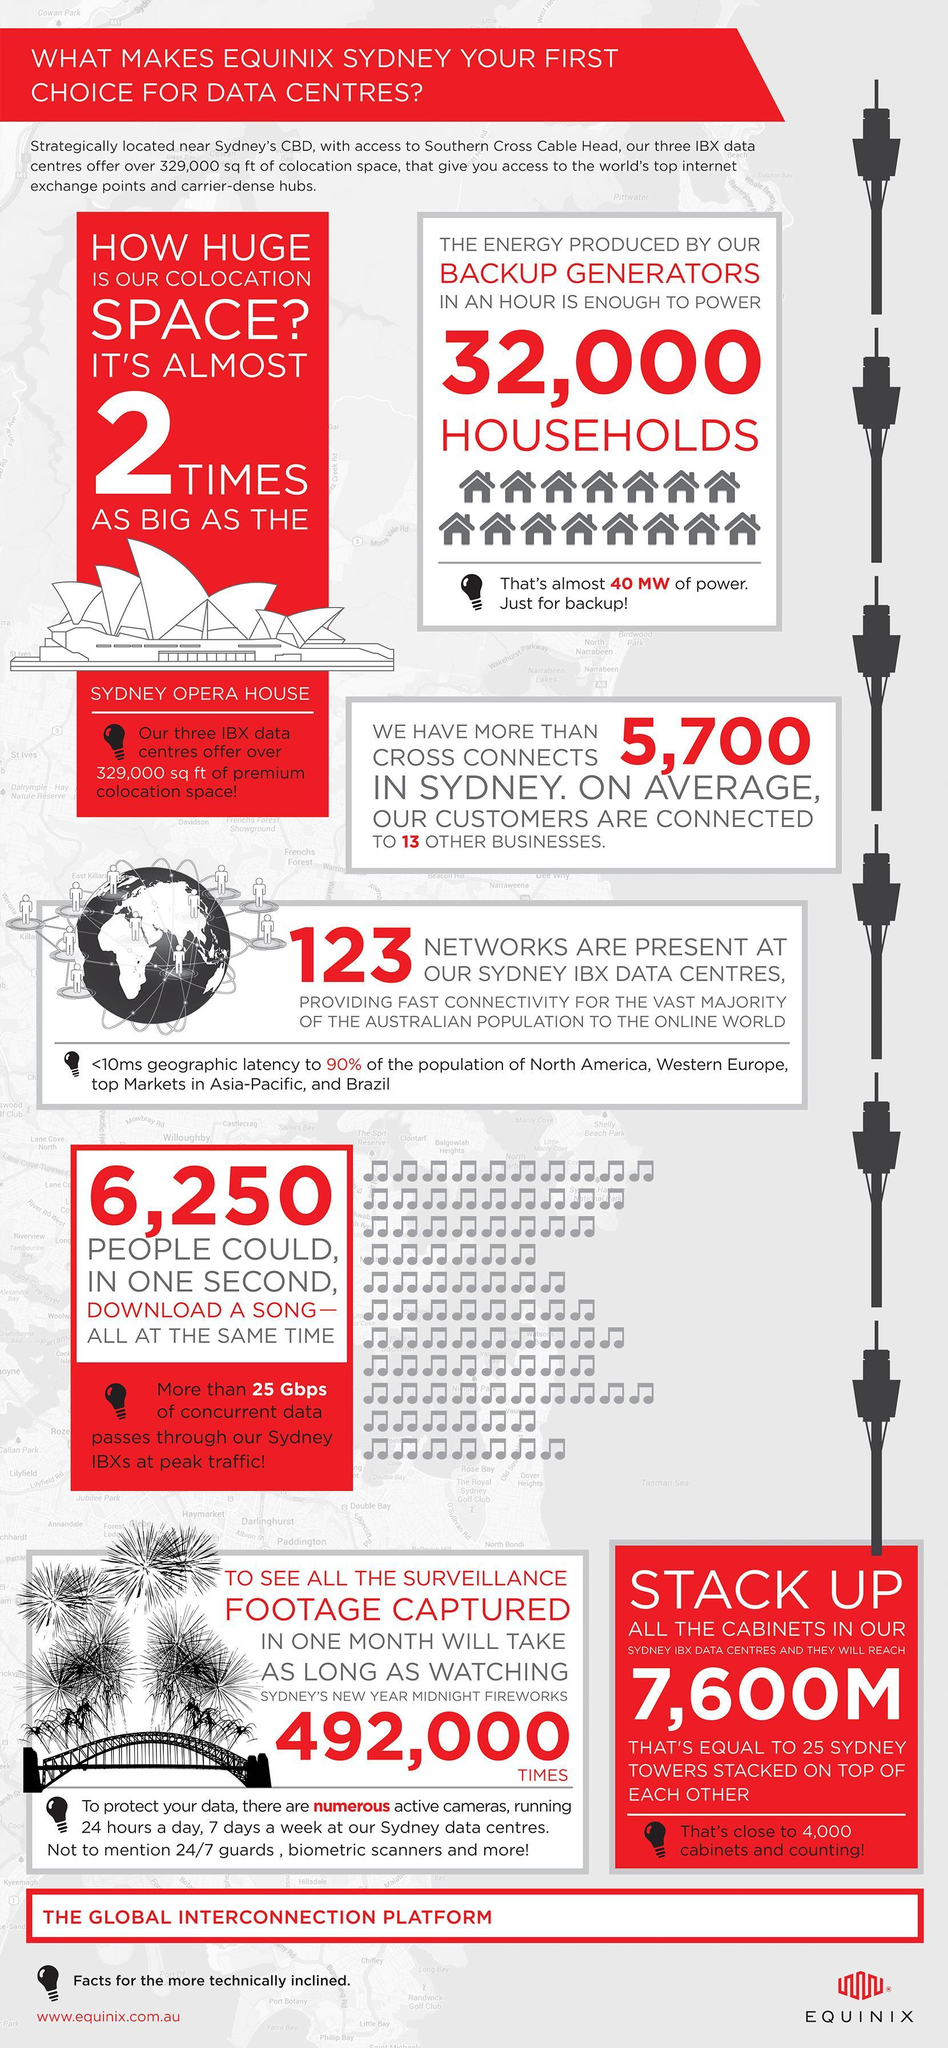How many people can download a song in one second, all at the same time?
Answer the question with a short phrase. 6,250 What is the number of networks at the Sydney IBX data centers? 123 How many households can be powered by the energy produced by the backup generators? 32,000 